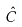<formula> <loc_0><loc_0><loc_500><loc_500>\hat { C }</formula> 